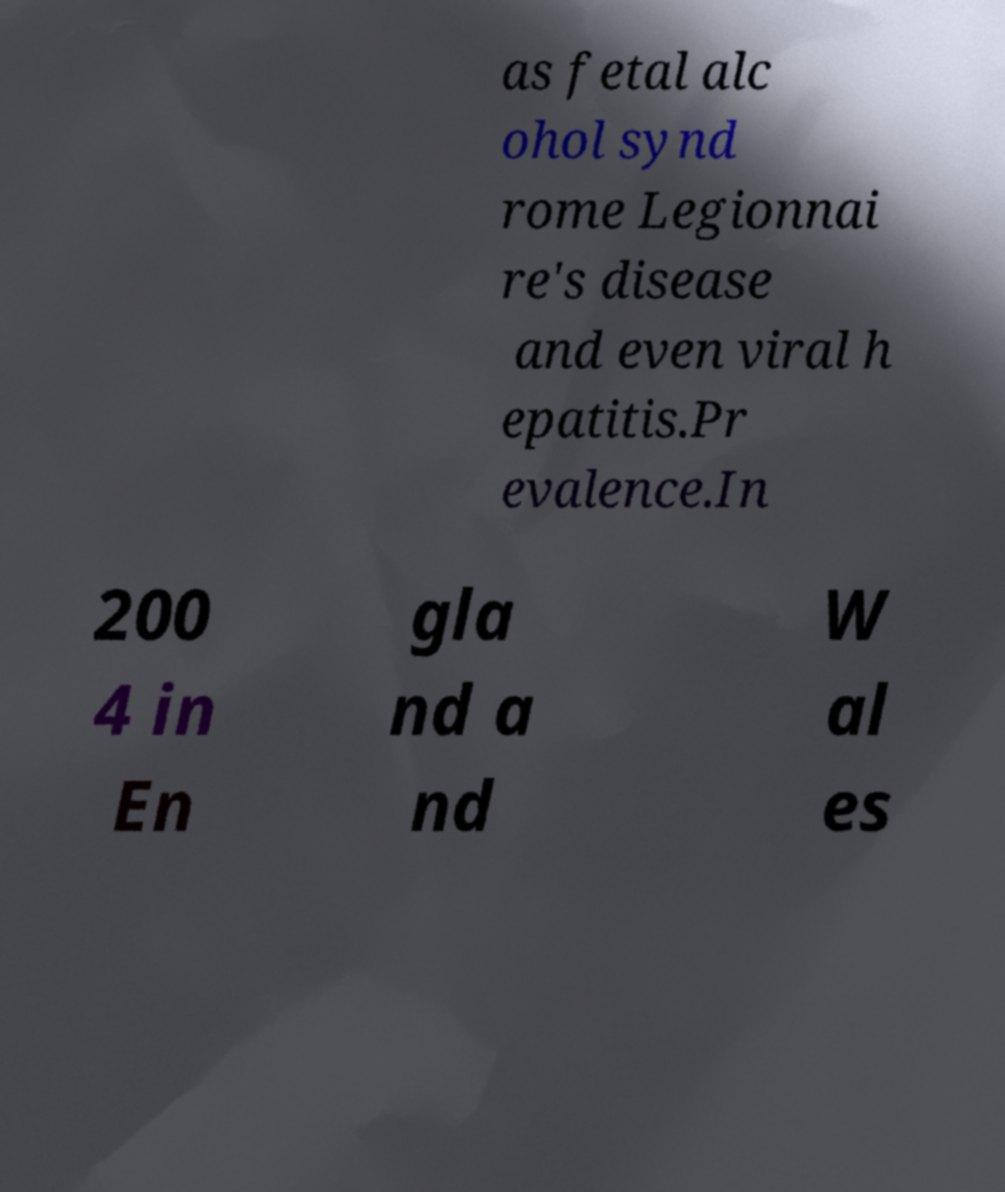Please read and relay the text visible in this image. What does it say? as fetal alc ohol synd rome Legionnai re's disease and even viral h epatitis.Pr evalence.In 200 4 in En gla nd a nd W al es 